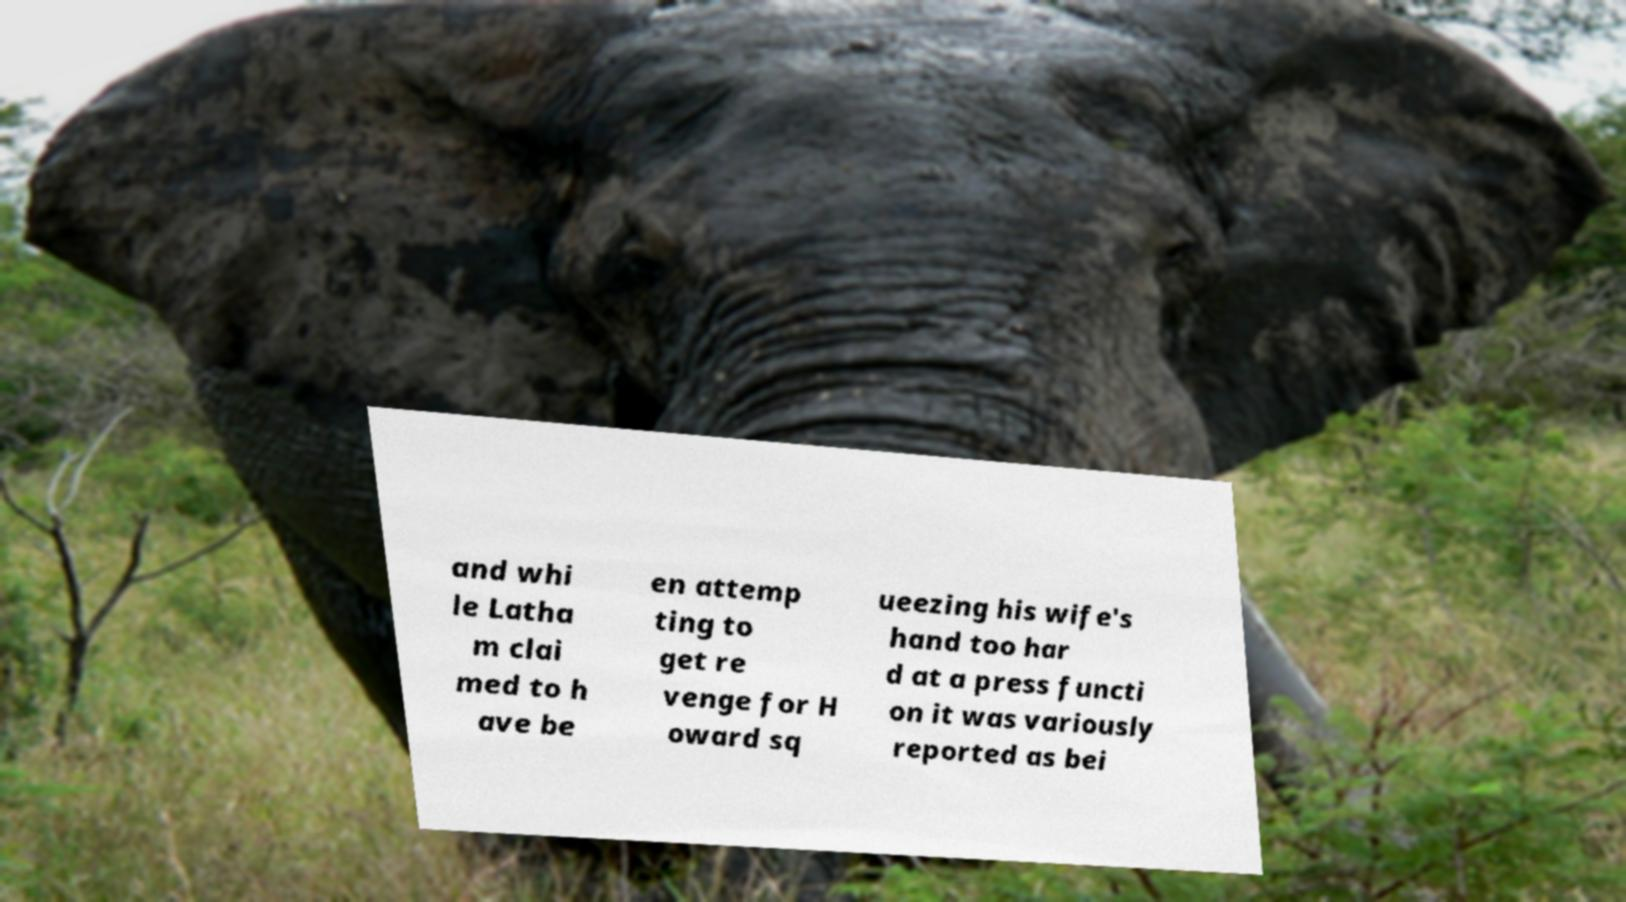Please read and relay the text visible in this image. What does it say? and whi le Latha m clai med to h ave be en attemp ting to get re venge for H oward sq ueezing his wife's hand too har d at a press functi on it was variously reported as bei 